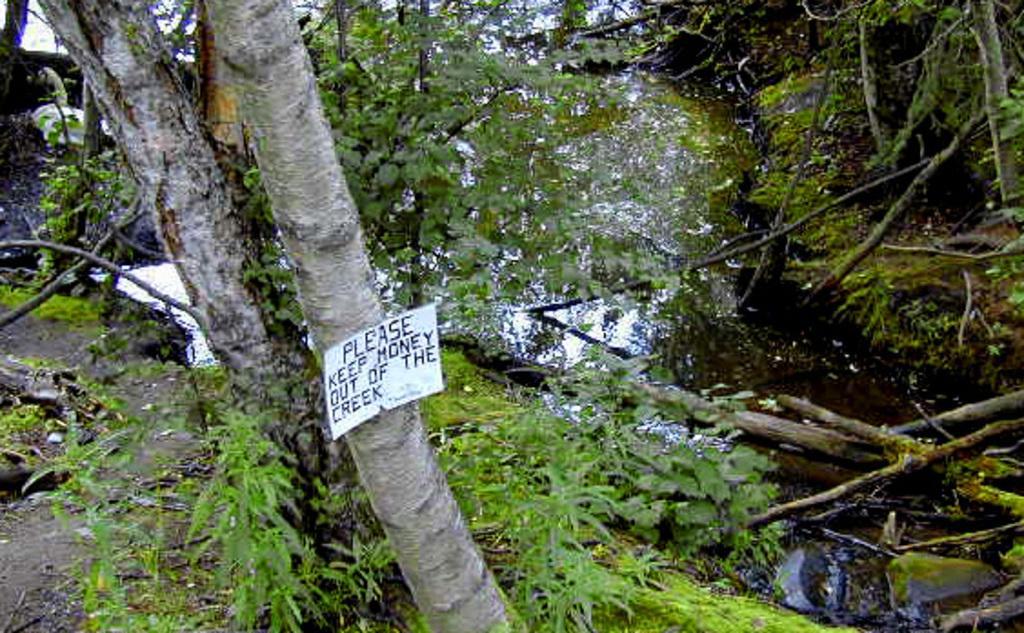In one or two sentences, can you explain what this image depicts? On the right side of this image there is a river. On both sides of the river I can see the grass, plants and trees. On the left side a white color board is attached to a tree trunk. On this I can see some text. 